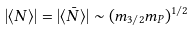<formula> <loc_0><loc_0><loc_500><loc_500>| \langle N \rangle | = | \langle \bar { N } \rangle | \sim ( m _ { 3 / 2 } m _ { P } ) ^ { 1 / 2 }</formula> 